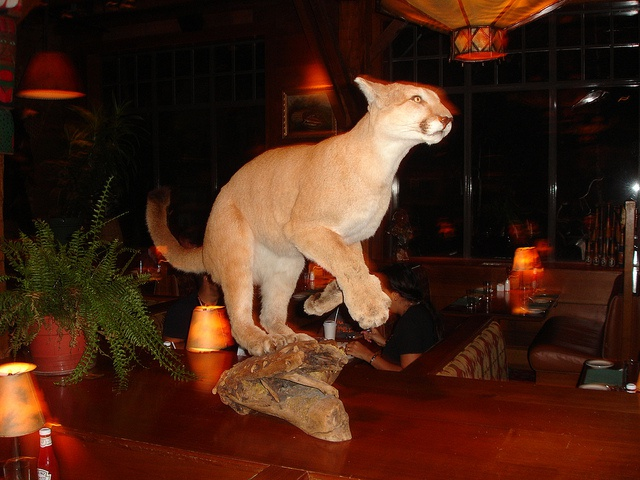Describe the objects in this image and their specific colors. I can see dining table in gray, maroon, and brown tones, cat in gray and tan tones, potted plant in gray, black, maroon, and darkgreen tones, people in gray, black, maroon, and brown tones, and chair in black, maroon, and gray tones in this image. 